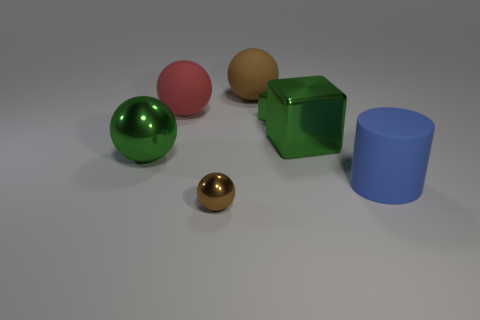Subtract all purple cylinders. Subtract all blue blocks. How many cylinders are left? 1 Add 1 tiny blue cylinders. How many objects exist? 8 Subtract all cylinders. How many objects are left? 6 Add 2 large blue cylinders. How many large blue cylinders are left? 3 Add 7 small yellow metal spheres. How many small yellow metal spheres exist? 7 Subtract 0 blue spheres. How many objects are left? 7 Subtract all brown metal objects. Subtract all blocks. How many objects are left? 4 